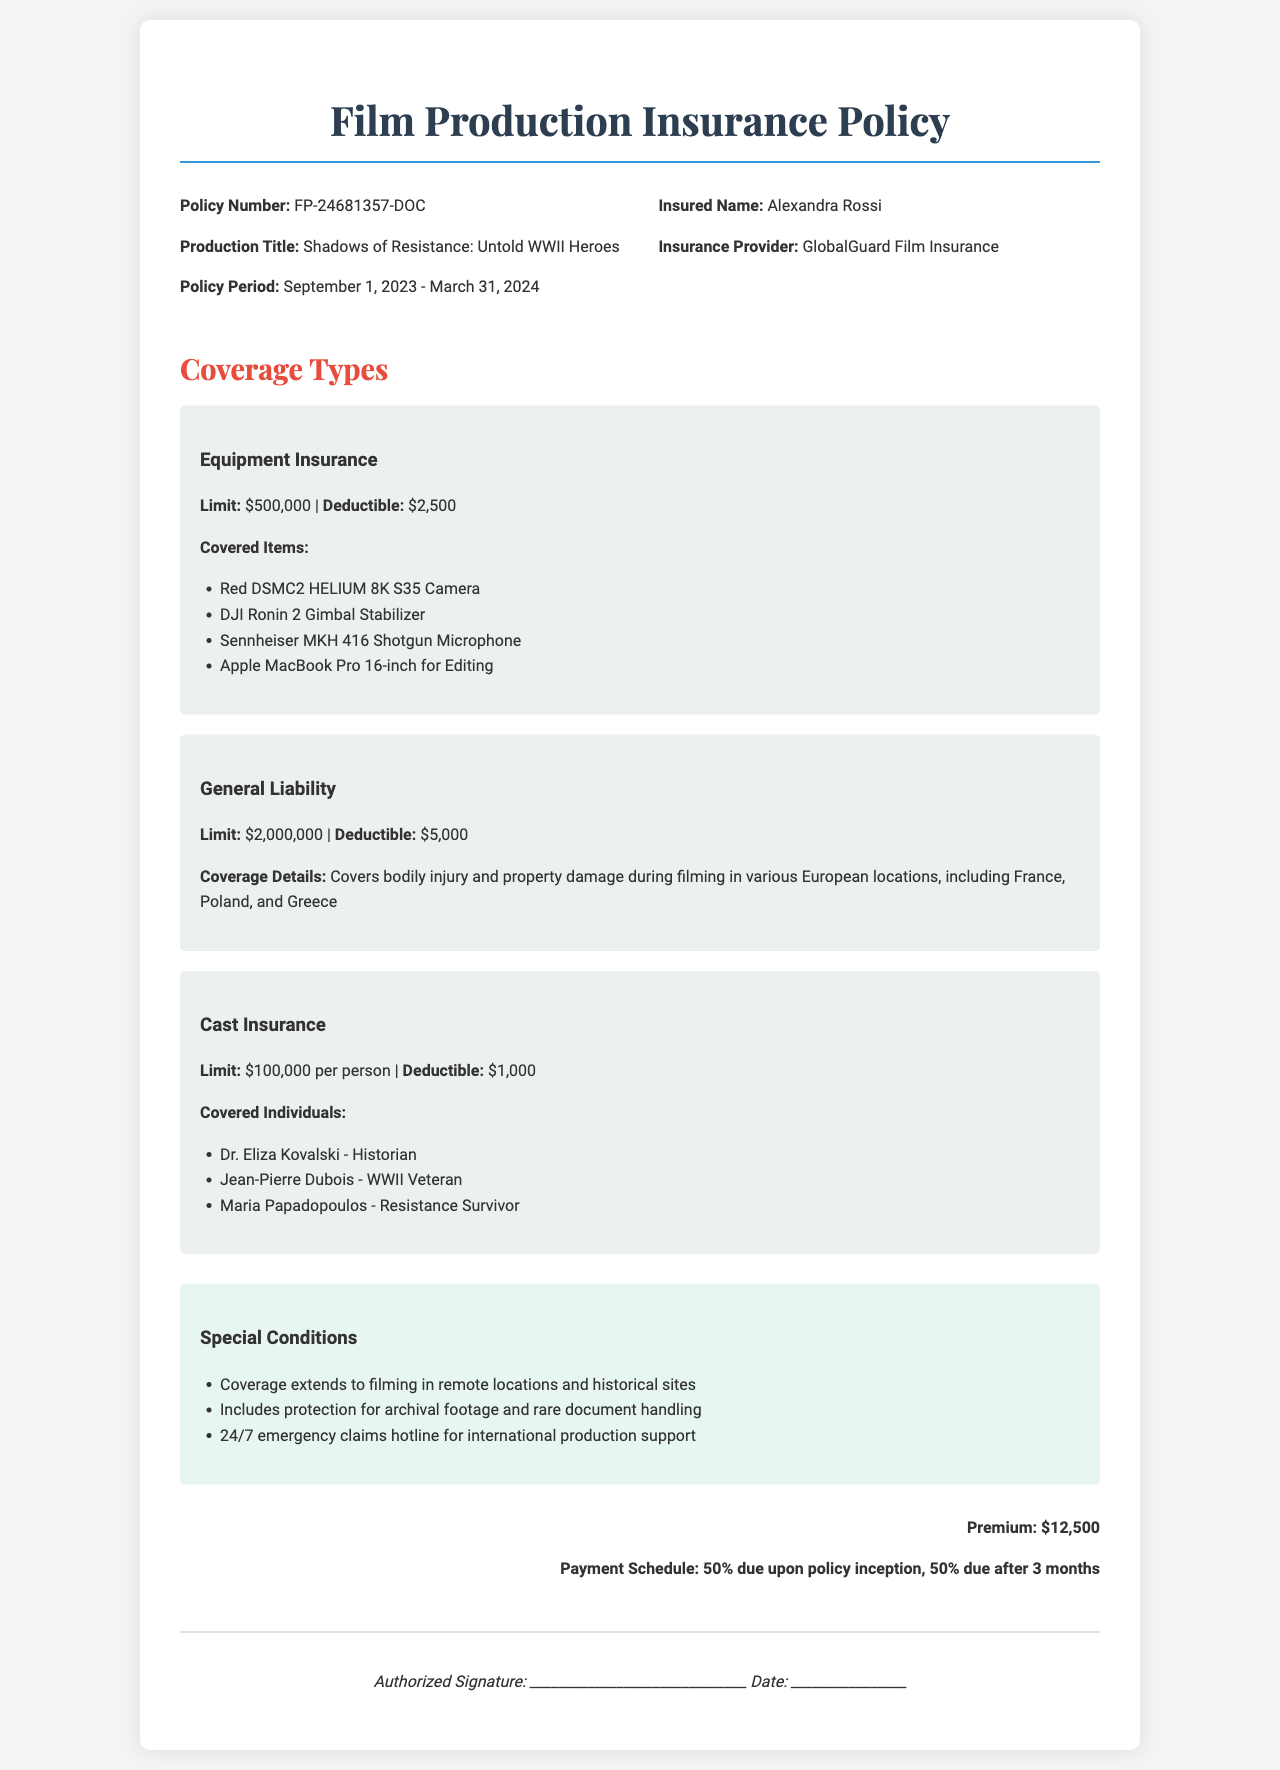What is the policy number? The policy number is directly mentioned under the policy information section.
Answer: FP-24681357-DOC Who is the insured name? The insured name is listed in the policy information, indicating who the policy is for.
Answer: Alexandra Rossi What is the limit for Equipment Insurance? The limit for Equipment Insurance can be found in the coverage types section specifically for Equipment Insurance.
Answer: $500,000 What is the deductible for General Liability? The deductible is specified in the General Liability coverage details.
Answer: $5,000 How many covered individuals are listed under Cast Insurance? The number of covered individuals can be counted from the list in the Cast Insurance section.
Answer: 3 What is the premium amount mentioned in the document? The premium amount is stated at the bottom of the document under the premium information section.
Answer: $12,500 Which camera is covered under Equipment Insurance? The specific camera is listed in the Equipment Insurance coverage details.
Answer: Red DSMC2 HELIUM 8K S35 Camera What is the policy period? The policy period specifies the dates during which the insurance is in effect and is found in the policy information.
Answer: September 1, 2023 - March 31, 2024 What special condition exists for filming locations? The special conditions section outlines additional requirements or protections related to filming.
Answer: Coverage extends to filming in remote locations and historical sites 